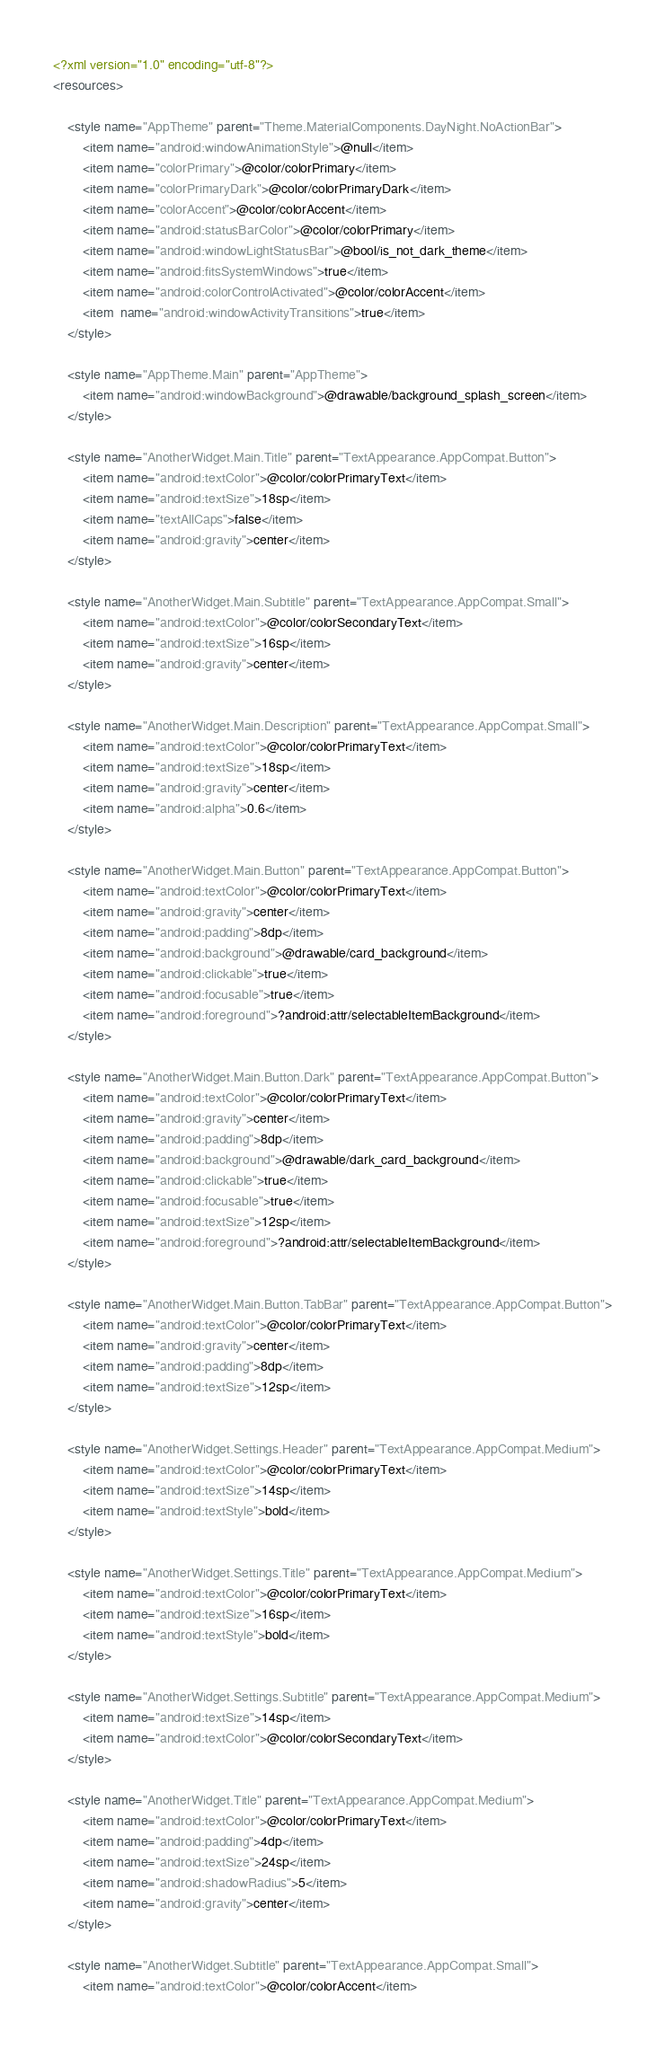Convert code to text. <code><loc_0><loc_0><loc_500><loc_500><_XML_><?xml version="1.0" encoding="utf-8"?>
<resources>

    <style name="AppTheme" parent="Theme.MaterialComponents.DayNight.NoActionBar">
        <item name="android:windowAnimationStyle">@null</item>
        <item name="colorPrimary">@color/colorPrimary</item>
        <item name="colorPrimaryDark">@color/colorPrimaryDark</item>
        <item name="colorAccent">@color/colorAccent</item>
        <item name="android:statusBarColor">@color/colorPrimary</item>
        <item name="android:windowLightStatusBar">@bool/is_not_dark_theme</item>
        <item name="android:fitsSystemWindows">true</item>
        <item name="android:colorControlActivated">@color/colorAccent</item>
        <item  name="android:windowActivityTransitions">true</item>
    </style>

    <style name="AppTheme.Main" parent="AppTheme">
        <item name="android:windowBackground">@drawable/background_splash_screen</item>
    </style>

    <style name="AnotherWidget.Main.Title" parent="TextAppearance.AppCompat.Button">
        <item name="android:textColor">@color/colorPrimaryText</item>
        <item name="android:textSize">18sp</item>
        <item name="textAllCaps">false</item>
        <item name="android:gravity">center</item>
    </style>

    <style name="AnotherWidget.Main.Subtitle" parent="TextAppearance.AppCompat.Small">
        <item name="android:textColor">@color/colorSecondaryText</item>
        <item name="android:textSize">16sp</item>
        <item name="android:gravity">center</item>
    </style>

    <style name="AnotherWidget.Main.Description" parent="TextAppearance.AppCompat.Small">
        <item name="android:textColor">@color/colorPrimaryText</item>
        <item name="android:textSize">18sp</item>
        <item name="android:gravity">center</item>
        <item name="android:alpha">0.6</item>
    </style>

    <style name="AnotherWidget.Main.Button" parent="TextAppearance.AppCompat.Button">
        <item name="android:textColor">@color/colorPrimaryText</item>
        <item name="android:gravity">center</item>
        <item name="android:padding">8dp</item>
        <item name="android:background">@drawable/card_background</item>
        <item name="android:clickable">true</item>
        <item name="android:focusable">true</item>
        <item name="android:foreground">?android:attr/selectableItemBackground</item>
    </style>

    <style name="AnotherWidget.Main.Button.Dark" parent="TextAppearance.AppCompat.Button">
        <item name="android:textColor">@color/colorPrimaryText</item>
        <item name="android:gravity">center</item>
        <item name="android:padding">8dp</item>
        <item name="android:background">@drawable/dark_card_background</item>
        <item name="android:clickable">true</item>
        <item name="android:focusable">true</item>
        <item name="android:textSize">12sp</item>
        <item name="android:foreground">?android:attr/selectableItemBackground</item>
    </style>

    <style name="AnotherWidget.Main.Button.TabBar" parent="TextAppearance.AppCompat.Button">
        <item name="android:textColor">@color/colorPrimaryText</item>
        <item name="android:gravity">center</item>
        <item name="android:padding">8dp</item>
        <item name="android:textSize">12sp</item>
    </style>

    <style name="AnotherWidget.Settings.Header" parent="TextAppearance.AppCompat.Medium">
        <item name="android:textColor">@color/colorPrimaryText</item>
        <item name="android:textSize">14sp</item>
        <item name="android:textStyle">bold</item>
    </style>

    <style name="AnotherWidget.Settings.Title" parent="TextAppearance.AppCompat.Medium">
        <item name="android:textColor">@color/colorPrimaryText</item>
        <item name="android:textSize">16sp</item>
        <item name="android:textStyle">bold</item>
    </style>

    <style name="AnotherWidget.Settings.Subtitle" parent="TextAppearance.AppCompat.Medium">
        <item name="android:textSize">14sp</item>
        <item name="android:textColor">@color/colorSecondaryText</item>
    </style>

    <style name="AnotherWidget.Title" parent="TextAppearance.AppCompat.Medium">
        <item name="android:textColor">@color/colorPrimaryText</item>
        <item name="android:padding">4dp</item>
        <item name="android:textSize">24sp</item>
        <item name="android:shadowRadius">5</item>
        <item name="android:gravity">center</item>
    </style>

    <style name="AnotherWidget.Subtitle" parent="TextAppearance.AppCompat.Small">
        <item name="android:textColor">@color/colorAccent</item></code> 